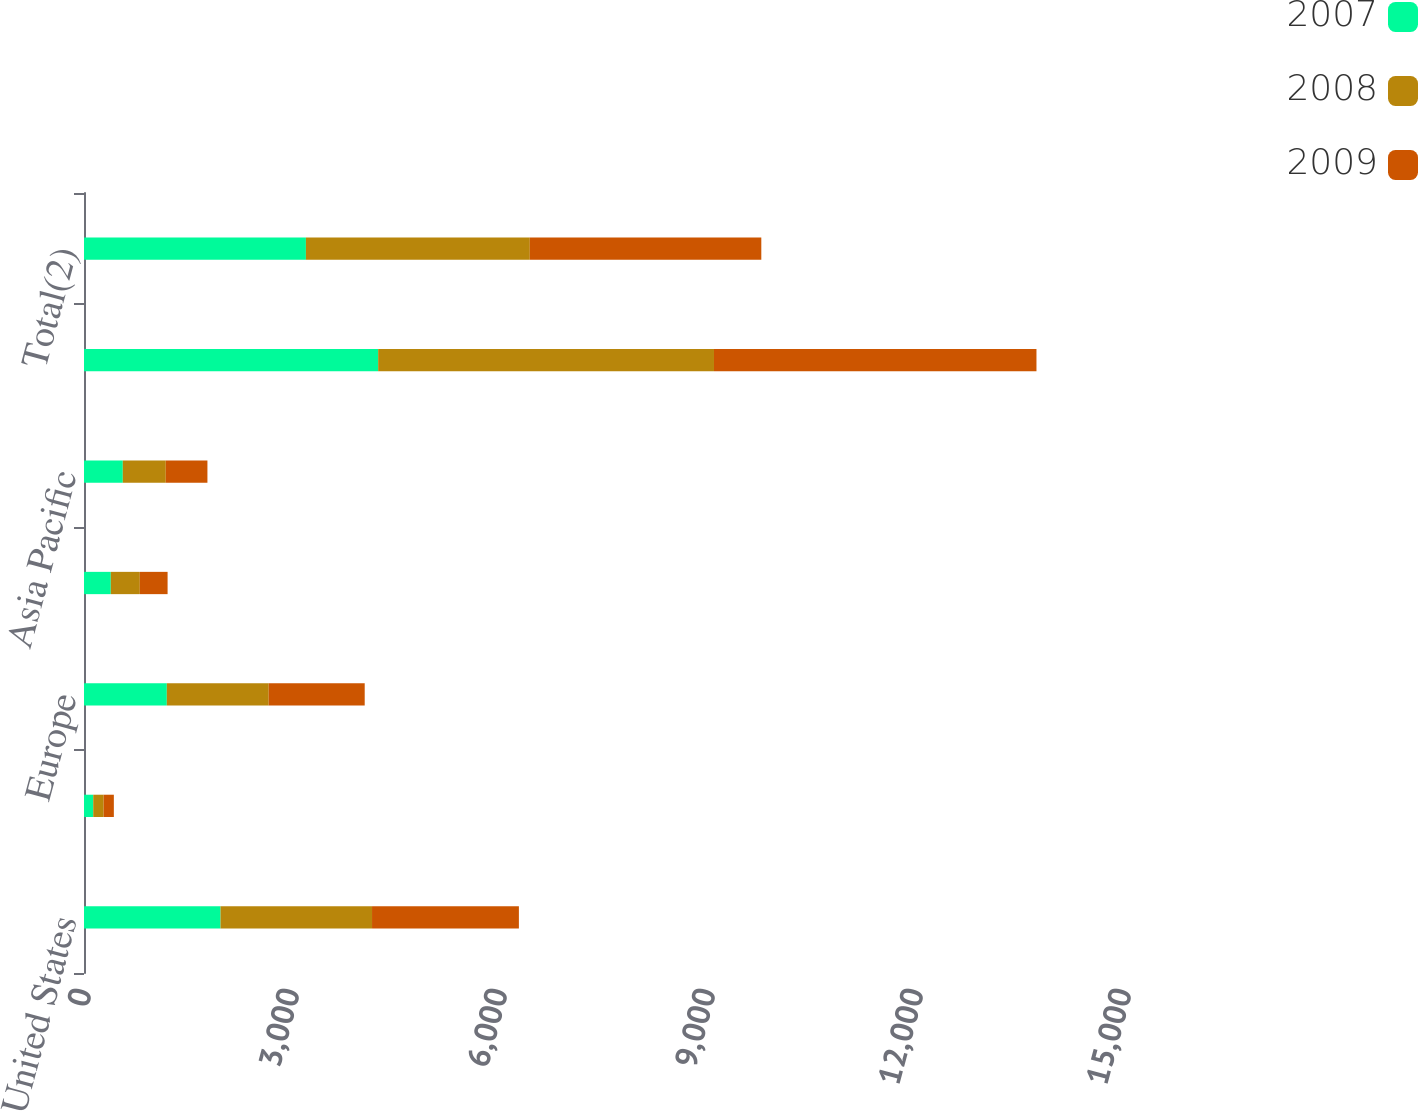Convert chart to OTSL. <chart><loc_0><loc_0><loc_500><loc_500><stacked_bar_chart><ecel><fcel>United States<fcel>Canada<fcel>Europe<fcel>Latin America<fcel>Asia Pacific<fcel>Total<fcel>Total(2)<nl><fcel>2007<fcel>1969.1<fcel>133.2<fcel>1194.5<fcel>386.4<fcel>559.6<fcel>4242.8<fcel>3200.7<nl><fcel>2008<fcel>2185.2<fcel>150.3<fcel>1469.6<fcel>418.5<fcel>619.9<fcel>4843.5<fcel>3229.2<nl><fcel>2009<fcel>2118.2<fcel>147<fcel>1384.6<fcel>400.7<fcel>600.7<fcel>4651.2<fcel>3339<nl></chart> 